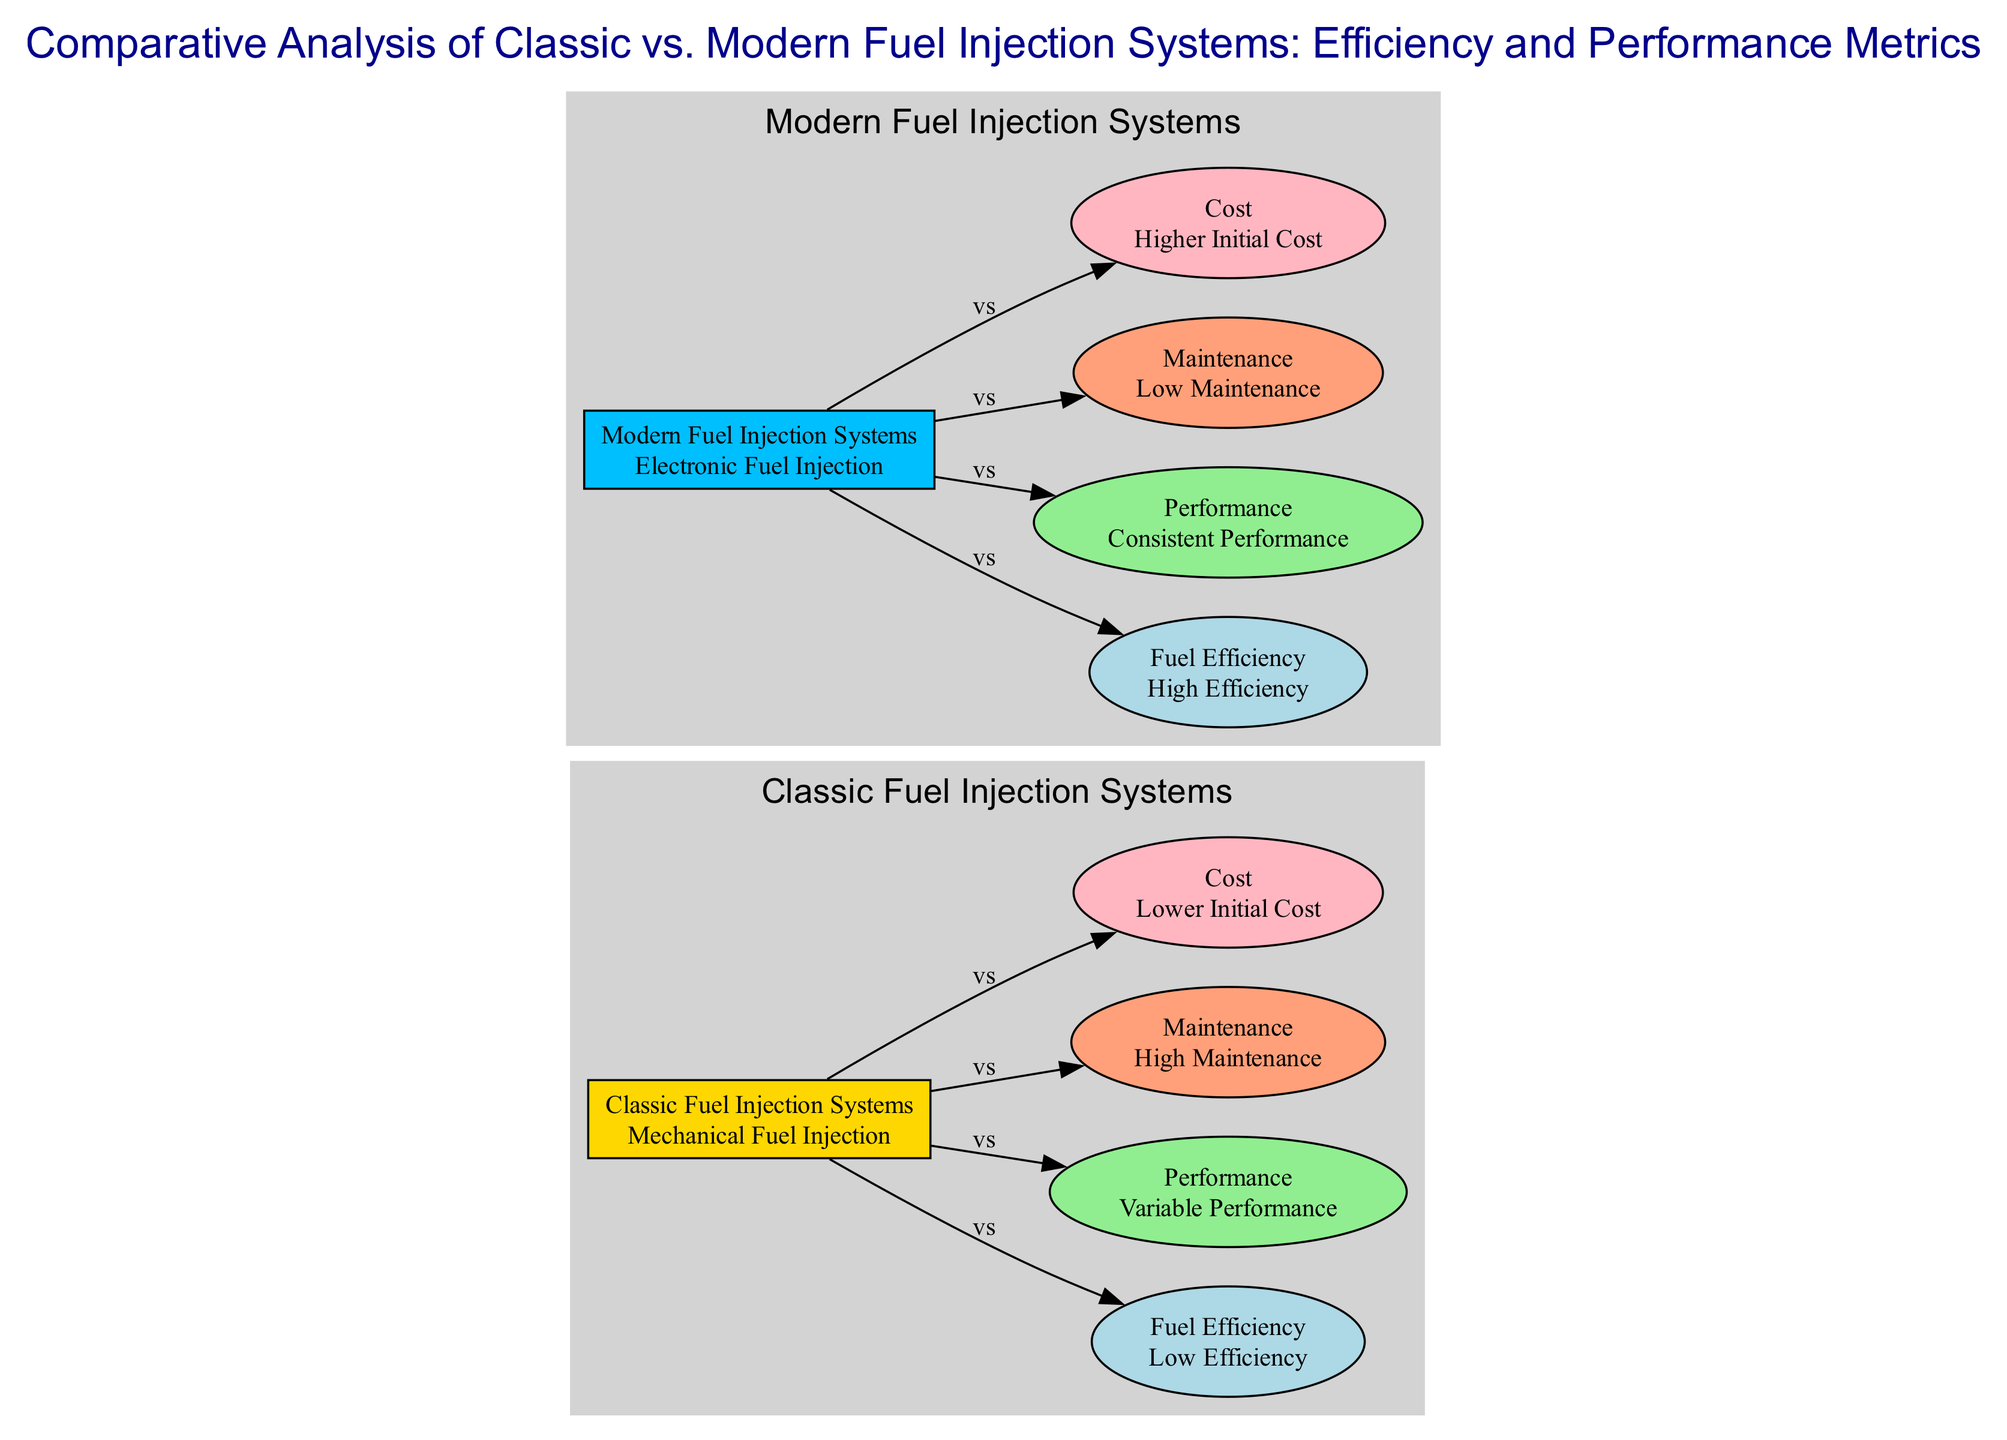What is the main type of injection system for classic cars? The diagram indicates that "Classic Fuel Injection Systems" refers to "Mechanical Fuel Injection". This is directly consistent with the node descriptions.
Answer: Mechanical Fuel Injection Which fuel injection system has higher fuel consumption? The comparison shows that under "Classic Fuel Injection Systems," the node "Fuel Efficiency" states "Low Efficiency" and mentions "Higher fuel consumption," contrasting with the modern systems.
Answer: Classic How many maintenance-related nodes are in the diagram? There are two nodes related to maintenance in the diagram: "Maintenance" for classic and "Maintenance" for modern systems. Therefore, a simple addition gives us two nodes focused on maintenance.
Answer: Two What is the comparison of initial costs between classic and modern systems? The edge connecting "Classic Fuel Injection Systems" to "Cost" indicates that the classic system has "Lower Initial Cost," while the modern system's cost is described as "Higher Initial Cost." This indicates a clear hierarchical comparison between both.
Answer: Lower Initial Cost Explain the relationship between classic fuel injection systems and performance. The diagram draws a connection between "Classic Fuel Injection Systems" and "Performance," which labels its performance as "Variable Performance". This indicates that classic systems have less control over the air-fuel mixture. Hence, the relationship shows that classic systems are less consistent in performance.
Answer: Variable Performance Which fuel injection system is associated with longer service intervals? The diagram shows that "Modern Fuel Injection Systems” leads to a node for "Maintenance" where it states "Low Maintenance" and "Longer service intervals," clarifying that modern systems require less frequent maintenance compared to classic systems.
Answer: Modern What type of control do modern fuel injection systems provide over the air-fuel mixture? The connection labeled "Performance" leads to “Consistent Performance” with the description of "Precise control over air-fuel ratio," indicating that modern systems have a defined and efficient way to manage the air-fuel mixture effectively.
Answer: Precise control How many edges connect classic systems to their respective performance and efficiency? The edges identified that connect classic systems lead to "Performance" and "Fuel Efficiency," totaling two edges specifically connecting classic systems to how they perform and their efficiency.
Answer: Two 